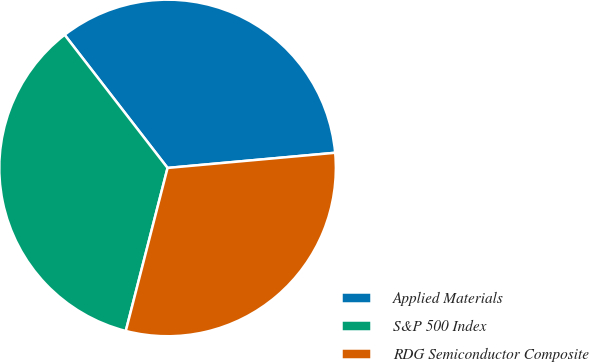Convert chart to OTSL. <chart><loc_0><loc_0><loc_500><loc_500><pie_chart><fcel>Applied Materials<fcel>S&P 500 Index<fcel>RDG Semiconductor Composite<nl><fcel>34.04%<fcel>35.53%<fcel>30.43%<nl></chart> 